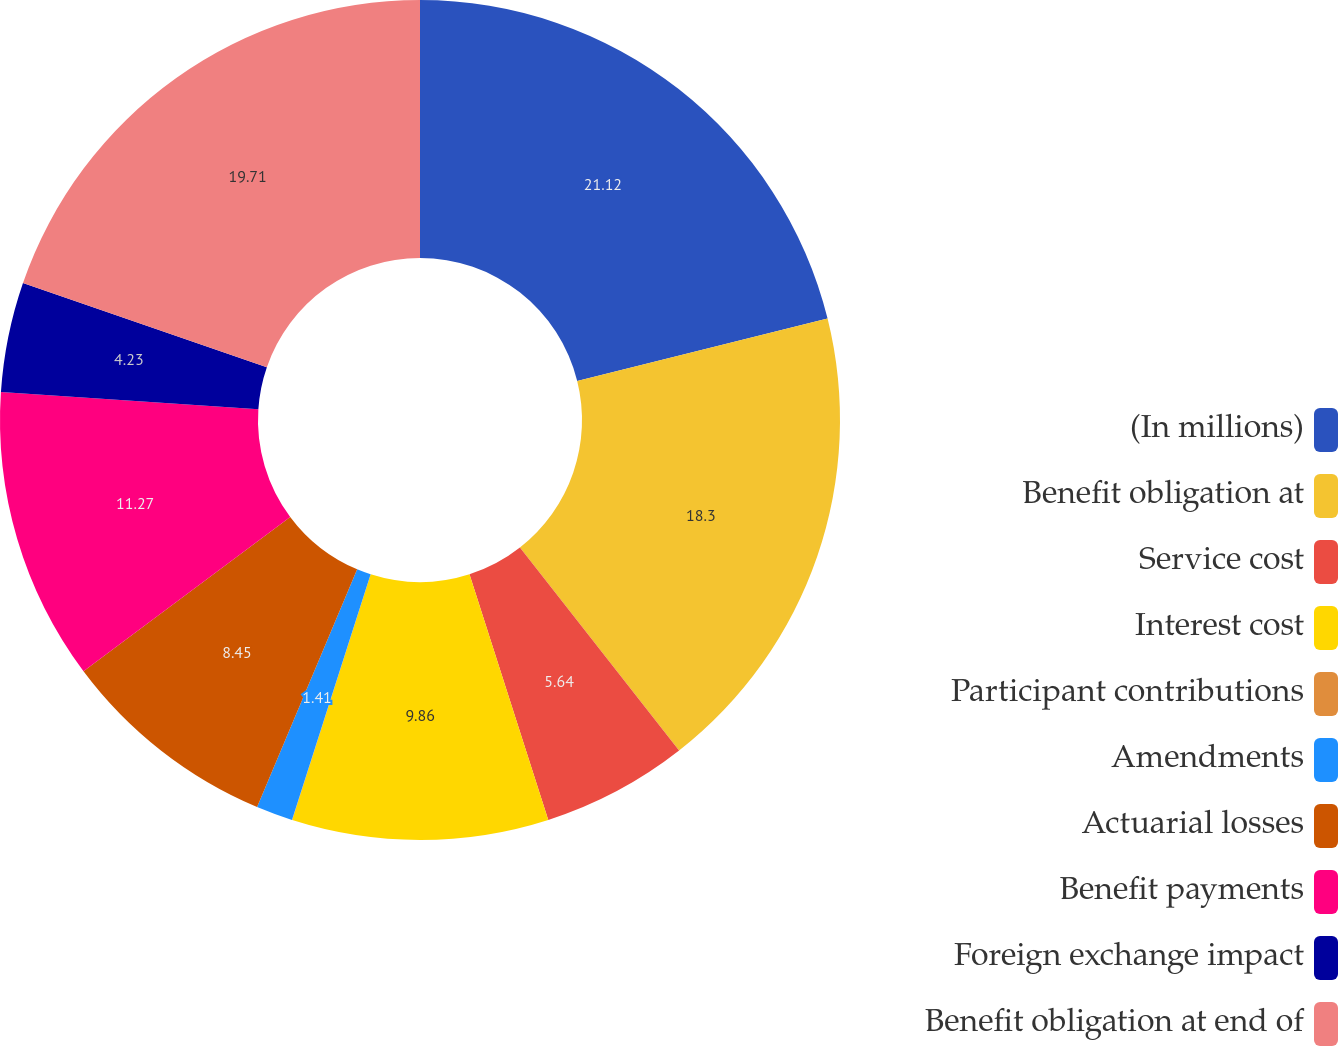<chart> <loc_0><loc_0><loc_500><loc_500><pie_chart><fcel>(In millions)<fcel>Benefit obligation at<fcel>Service cost<fcel>Interest cost<fcel>Participant contributions<fcel>Amendments<fcel>Actuarial losses<fcel>Benefit payments<fcel>Foreign exchange impact<fcel>Benefit obligation at end of<nl><fcel>21.12%<fcel>18.3%<fcel>5.64%<fcel>9.86%<fcel>0.01%<fcel>1.41%<fcel>8.45%<fcel>11.27%<fcel>4.23%<fcel>19.71%<nl></chart> 